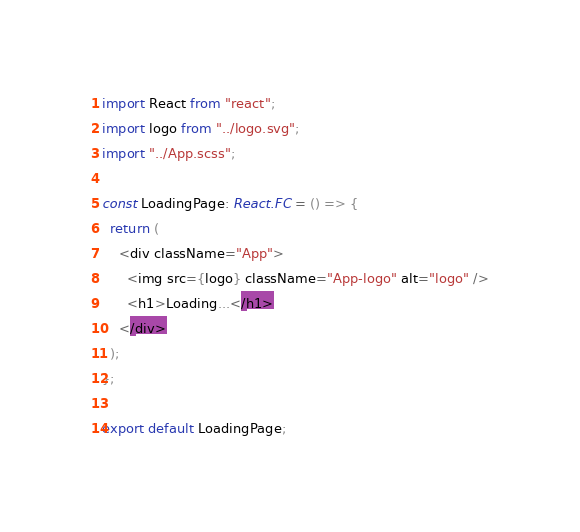<code> <loc_0><loc_0><loc_500><loc_500><_TypeScript_>import React from "react";
import logo from "../logo.svg";
import "../App.scss";

const LoadingPage: React.FC = () => {
  return (
    <div className="App">
      <img src={logo} className="App-logo" alt="logo" />
      <h1>Loading...</h1>
    </div>
  );
};

export default LoadingPage;
</code> 